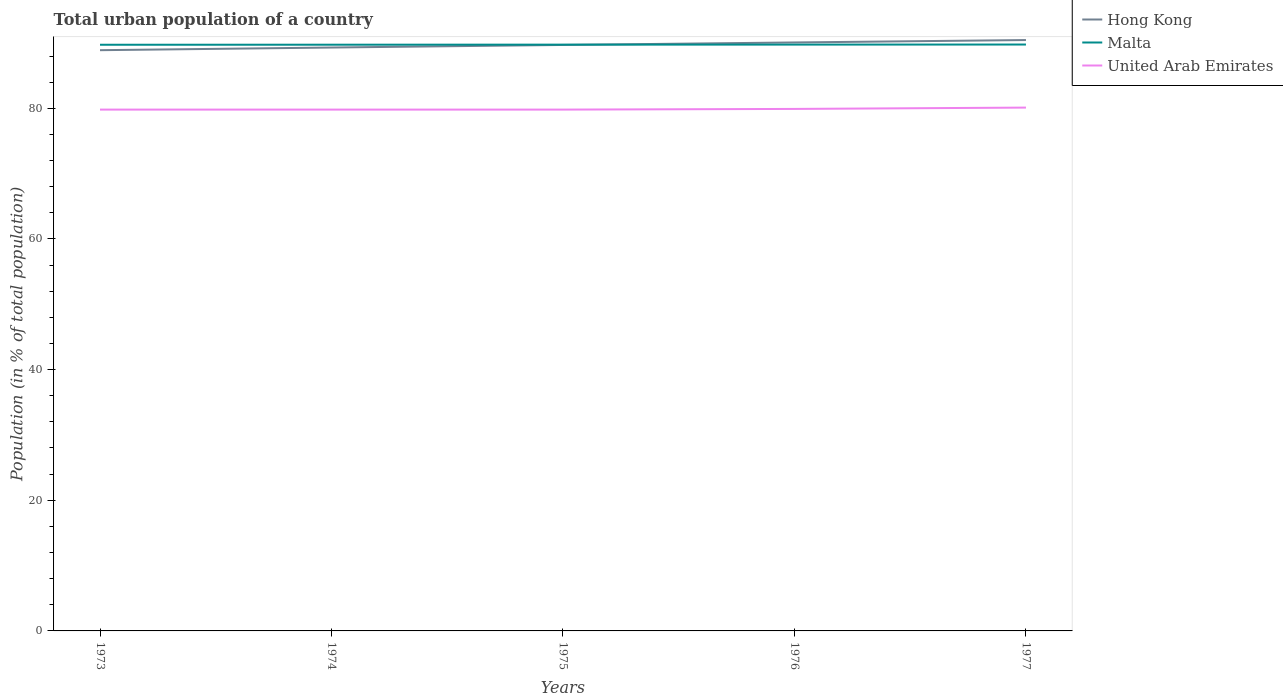Does the line corresponding to United Arab Emirates intersect with the line corresponding to Hong Kong?
Your answer should be very brief. No. Across all years, what is the maximum urban population in Malta?
Provide a short and direct response. 89.72. In which year was the urban population in Malta maximum?
Provide a short and direct response. 1973. What is the total urban population in Hong Kong in the graph?
Make the answer very short. -1.14. What is the difference between the highest and the second highest urban population in Hong Kong?
Provide a short and direct response. 1.55. What is the difference between the highest and the lowest urban population in Hong Kong?
Keep it short and to the point. 3. Is the urban population in Malta strictly greater than the urban population in Hong Kong over the years?
Your answer should be compact. No. How many years are there in the graph?
Your answer should be very brief. 5. How are the legend labels stacked?
Your answer should be very brief. Vertical. What is the title of the graph?
Keep it short and to the point. Total urban population of a country. What is the label or title of the Y-axis?
Provide a short and direct response. Population (in % of total population). What is the Population (in % of total population) in Hong Kong in 1973?
Make the answer very short. 88.89. What is the Population (in % of total population) of Malta in 1973?
Ensure brevity in your answer.  89.72. What is the Population (in % of total population) in United Arab Emirates in 1973?
Provide a short and direct response. 79.8. What is the Population (in % of total population) in Hong Kong in 1974?
Your answer should be very brief. 89.3. What is the Population (in % of total population) in Malta in 1974?
Ensure brevity in your answer.  89.73. What is the Population (in % of total population) of United Arab Emirates in 1974?
Offer a terse response. 79.8. What is the Population (in % of total population) in Hong Kong in 1975?
Give a very brief answer. 89.69. What is the Population (in % of total population) in Malta in 1975?
Your answer should be compact. 89.74. What is the Population (in % of total population) of United Arab Emirates in 1975?
Your response must be concise. 79.8. What is the Population (in % of total population) in Hong Kong in 1976?
Your answer should be very brief. 90.08. What is the Population (in % of total population) in Malta in 1976?
Your response must be concise. 89.75. What is the Population (in % of total population) of United Arab Emirates in 1976?
Provide a short and direct response. 79.9. What is the Population (in % of total population) of Hong Kong in 1977?
Your response must be concise. 90.44. What is the Population (in % of total population) of Malta in 1977?
Offer a terse response. 89.76. What is the Population (in % of total population) in United Arab Emirates in 1977?
Give a very brief answer. 80.11. Across all years, what is the maximum Population (in % of total population) in Hong Kong?
Provide a short and direct response. 90.44. Across all years, what is the maximum Population (in % of total population) of Malta?
Offer a terse response. 89.76. Across all years, what is the maximum Population (in % of total population) of United Arab Emirates?
Offer a terse response. 80.11. Across all years, what is the minimum Population (in % of total population) in Hong Kong?
Your response must be concise. 88.89. Across all years, what is the minimum Population (in % of total population) in Malta?
Provide a succinct answer. 89.72. Across all years, what is the minimum Population (in % of total population) of United Arab Emirates?
Your answer should be very brief. 79.8. What is the total Population (in % of total population) in Hong Kong in the graph?
Offer a terse response. 448.41. What is the total Population (in % of total population) in Malta in the graph?
Provide a short and direct response. 448.71. What is the total Population (in % of total population) in United Arab Emirates in the graph?
Make the answer very short. 399.41. What is the difference between the Population (in % of total population) of Hong Kong in 1973 and that in 1974?
Offer a terse response. -0.41. What is the difference between the Population (in % of total population) in Malta in 1973 and that in 1974?
Offer a terse response. -0.01. What is the difference between the Population (in % of total population) in United Arab Emirates in 1973 and that in 1974?
Your response must be concise. 0. What is the difference between the Population (in % of total population) in Hong Kong in 1973 and that in 1975?
Offer a terse response. -0.8. What is the difference between the Population (in % of total population) of Malta in 1973 and that in 1975?
Make the answer very short. -0.02. What is the difference between the Population (in % of total population) in Hong Kong in 1973 and that in 1976?
Keep it short and to the point. -1.18. What is the difference between the Population (in % of total population) in Malta in 1973 and that in 1976?
Ensure brevity in your answer.  -0.03. What is the difference between the Population (in % of total population) of United Arab Emirates in 1973 and that in 1976?
Your response must be concise. -0.1. What is the difference between the Population (in % of total population) in Hong Kong in 1973 and that in 1977?
Make the answer very short. -1.55. What is the difference between the Population (in % of total population) of Malta in 1973 and that in 1977?
Keep it short and to the point. -0.04. What is the difference between the Population (in % of total population) of United Arab Emirates in 1973 and that in 1977?
Your answer should be very brief. -0.31. What is the difference between the Population (in % of total population) in Hong Kong in 1974 and that in 1975?
Give a very brief answer. -0.39. What is the difference between the Population (in % of total population) of Malta in 1974 and that in 1975?
Ensure brevity in your answer.  -0.01. What is the difference between the Population (in % of total population) in United Arab Emirates in 1974 and that in 1975?
Ensure brevity in your answer.  0. What is the difference between the Population (in % of total population) of Hong Kong in 1974 and that in 1976?
Keep it short and to the point. -0.78. What is the difference between the Population (in % of total population) in Malta in 1974 and that in 1976?
Provide a succinct answer. -0.02. What is the difference between the Population (in % of total population) of United Arab Emirates in 1974 and that in 1976?
Offer a very short reply. -0.1. What is the difference between the Population (in % of total population) in Hong Kong in 1974 and that in 1977?
Offer a very short reply. -1.14. What is the difference between the Population (in % of total population) in Malta in 1974 and that in 1977?
Provide a short and direct response. -0.03. What is the difference between the Population (in % of total population) of United Arab Emirates in 1974 and that in 1977?
Offer a very short reply. -0.31. What is the difference between the Population (in % of total population) of Hong Kong in 1975 and that in 1976?
Make the answer very short. -0.38. What is the difference between the Population (in % of total population) in Malta in 1975 and that in 1976?
Offer a terse response. -0.01. What is the difference between the Population (in % of total population) of United Arab Emirates in 1975 and that in 1976?
Offer a terse response. -0.1. What is the difference between the Population (in % of total population) in Hong Kong in 1975 and that in 1977?
Provide a succinct answer. -0.75. What is the difference between the Population (in % of total population) of Malta in 1975 and that in 1977?
Your answer should be very brief. -0.02. What is the difference between the Population (in % of total population) of United Arab Emirates in 1975 and that in 1977?
Ensure brevity in your answer.  -0.31. What is the difference between the Population (in % of total population) in Hong Kong in 1976 and that in 1977?
Your response must be concise. -0.37. What is the difference between the Population (in % of total population) of Malta in 1976 and that in 1977?
Provide a succinct answer. -0.01. What is the difference between the Population (in % of total population) in United Arab Emirates in 1976 and that in 1977?
Keep it short and to the point. -0.2. What is the difference between the Population (in % of total population) of Hong Kong in 1973 and the Population (in % of total population) of Malta in 1974?
Provide a succinct answer. -0.84. What is the difference between the Population (in % of total population) in Hong Kong in 1973 and the Population (in % of total population) in United Arab Emirates in 1974?
Offer a terse response. 9.09. What is the difference between the Population (in % of total population) in Malta in 1973 and the Population (in % of total population) in United Arab Emirates in 1974?
Ensure brevity in your answer.  9.93. What is the difference between the Population (in % of total population) in Hong Kong in 1973 and the Population (in % of total population) in Malta in 1975?
Your response must be concise. -0.85. What is the difference between the Population (in % of total population) of Hong Kong in 1973 and the Population (in % of total population) of United Arab Emirates in 1975?
Give a very brief answer. 9.09. What is the difference between the Population (in % of total population) of Malta in 1973 and the Population (in % of total population) of United Arab Emirates in 1975?
Provide a succinct answer. 9.93. What is the difference between the Population (in % of total population) in Hong Kong in 1973 and the Population (in % of total population) in Malta in 1976?
Provide a short and direct response. -0.86. What is the difference between the Population (in % of total population) of Hong Kong in 1973 and the Population (in % of total population) of United Arab Emirates in 1976?
Ensure brevity in your answer.  8.99. What is the difference between the Population (in % of total population) in Malta in 1973 and the Population (in % of total population) in United Arab Emirates in 1976?
Offer a very short reply. 9.82. What is the difference between the Population (in % of total population) of Hong Kong in 1973 and the Population (in % of total population) of Malta in 1977?
Your answer should be compact. -0.87. What is the difference between the Population (in % of total population) in Hong Kong in 1973 and the Population (in % of total population) in United Arab Emirates in 1977?
Offer a very short reply. 8.79. What is the difference between the Population (in % of total population) in Malta in 1973 and the Population (in % of total population) in United Arab Emirates in 1977?
Your answer should be very brief. 9.62. What is the difference between the Population (in % of total population) of Hong Kong in 1974 and the Population (in % of total population) of Malta in 1975?
Keep it short and to the point. -0.44. What is the difference between the Population (in % of total population) in Hong Kong in 1974 and the Population (in % of total population) in United Arab Emirates in 1975?
Offer a very short reply. 9.5. What is the difference between the Population (in % of total population) in Malta in 1974 and the Population (in % of total population) in United Arab Emirates in 1975?
Provide a short and direct response. 9.93. What is the difference between the Population (in % of total population) of Hong Kong in 1974 and the Population (in % of total population) of Malta in 1976?
Give a very brief answer. -0.45. What is the difference between the Population (in % of total population) of Hong Kong in 1974 and the Population (in % of total population) of United Arab Emirates in 1976?
Ensure brevity in your answer.  9.4. What is the difference between the Population (in % of total population) in Malta in 1974 and the Population (in % of total population) in United Arab Emirates in 1976?
Give a very brief answer. 9.83. What is the difference between the Population (in % of total population) in Hong Kong in 1974 and the Population (in % of total population) in Malta in 1977?
Your answer should be very brief. -0.46. What is the difference between the Population (in % of total population) in Hong Kong in 1974 and the Population (in % of total population) in United Arab Emirates in 1977?
Offer a very short reply. 9.2. What is the difference between the Population (in % of total population) of Malta in 1974 and the Population (in % of total population) of United Arab Emirates in 1977?
Your answer should be compact. 9.63. What is the difference between the Population (in % of total population) in Hong Kong in 1975 and the Population (in % of total population) in Malta in 1976?
Ensure brevity in your answer.  -0.06. What is the difference between the Population (in % of total population) in Hong Kong in 1975 and the Population (in % of total population) in United Arab Emirates in 1976?
Your answer should be compact. 9.79. What is the difference between the Population (in % of total population) in Malta in 1975 and the Population (in % of total population) in United Arab Emirates in 1976?
Ensure brevity in your answer.  9.84. What is the difference between the Population (in % of total population) in Hong Kong in 1975 and the Population (in % of total population) in Malta in 1977?
Your answer should be very brief. -0.07. What is the difference between the Population (in % of total population) of Hong Kong in 1975 and the Population (in % of total population) of United Arab Emirates in 1977?
Ensure brevity in your answer.  9.59. What is the difference between the Population (in % of total population) of Malta in 1975 and the Population (in % of total population) of United Arab Emirates in 1977?
Your response must be concise. 9.64. What is the difference between the Population (in % of total population) of Hong Kong in 1976 and the Population (in % of total population) of Malta in 1977?
Make the answer very short. 0.32. What is the difference between the Population (in % of total population) of Hong Kong in 1976 and the Population (in % of total population) of United Arab Emirates in 1977?
Ensure brevity in your answer.  9.97. What is the difference between the Population (in % of total population) of Malta in 1976 and the Population (in % of total population) of United Arab Emirates in 1977?
Make the answer very short. 9.64. What is the average Population (in % of total population) of Hong Kong per year?
Your answer should be very brief. 89.68. What is the average Population (in % of total population) of Malta per year?
Keep it short and to the point. 89.74. What is the average Population (in % of total population) of United Arab Emirates per year?
Provide a succinct answer. 79.88. In the year 1973, what is the difference between the Population (in % of total population) in Hong Kong and Population (in % of total population) in Malta?
Give a very brief answer. -0.83. In the year 1973, what is the difference between the Population (in % of total population) in Hong Kong and Population (in % of total population) in United Arab Emirates?
Give a very brief answer. 9.09. In the year 1973, what is the difference between the Population (in % of total population) of Malta and Population (in % of total population) of United Arab Emirates?
Offer a terse response. 9.93. In the year 1974, what is the difference between the Population (in % of total population) of Hong Kong and Population (in % of total population) of Malta?
Make the answer very short. -0.43. In the year 1974, what is the difference between the Population (in % of total population) in Hong Kong and Population (in % of total population) in United Arab Emirates?
Keep it short and to the point. 9.5. In the year 1974, what is the difference between the Population (in % of total population) of Malta and Population (in % of total population) of United Arab Emirates?
Make the answer very short. 9.93. In the year 1975, what is the difference between the Population (in % of total population) of Hong Kong and Population (in % of total population) of Malta?
Give a very brief answer. -0.05. In the year 1975, what is the difference between the Population (in % of total population) in Hong Kong and Population (in % of total population) in United Arab Emirates?
Your answer should be compact. 9.89. In the year 1975, what is the difference between the Population (in % of total population) in Malta and Population (in % of total population) in United Arab Emirates?
Offer a terse response. 9.94. In the year 1976, what is the difference between the Population (in % of total population) of Hong Kong and Population (in % of total population) of Malta?
Provide a short and direct response. 0.33. In the year 1976, what is the difference between the Population (in % of total population) in Hong Kong and Population (in % of total population) in United Arab Emirates?
Make the answer very short. 10.17. In the year 1976, what is the difference between the Population (in % of total population) of Malta and Population (in % of total population) of United Arab Emirates?
Provide a short and direct response. 9.85. In the year 1977, what is the difference between the Population (in % of total population) in Hong Kong and Population (in % of total population) in Malta?
Provide a short and direct response. 0.69. In the year 1977, what is the difference between the Population (in % of total population) of Hong Kong and Population (in % of total population) of United Arab Emirates?
Your response must be concise. 10.34. In the year 1977, what is the difference between the Population (in % of total population) in Malta and Population (in % of total population) in United Arab Emirates?
Offer a terse response. 9.65. What is the ratio of the Population (in % of total population) in Hong Kong in 1973 to that in 1974?
Offer a very short reply. 1. What is the ratio of the Population (in % of total population) of Hong Kong in 1973 to that in 1976?
Make the answer very short. 0.99. What is the ratio of the Population (in % of total population) of Malta in 1973 to that in 1976?
Your response must be concise. 1. What is the ratio of the Population (in % of total population) in United Arab Emirates in 1973 to that in 1976?
Your answer should be very brief. 1. What is the ratio of the Population (in % of total population) in Hong Kong in 1973 to that in 1977?
Offer a terse response. 0.98. What is the ratio of the Population (in % of total population) in Malta in 1973 to that in 1977?
Your answer should be compact. 1. What is the ratio of the Population (in % of total population) of United Arab Emirates in 1973 to that in 1977?
Offer a very short reply. 1. What is the ratio of the Population (in % of total population) of Hong Kong in 1974 to that in 1975?
Keep it short and to the point. 1. What is the ratio of the Population (in % of total population) of Malta in 1974 to that in 1975?
Offer a very short reply. 1. What is the ratio of the Population (in % of total population) of Hong Kong in 1974 to that in 1976?
Your answer should be compact. 0.99. What is the ratio of the Population (in % of total population) of Malta in 1974 to that in 1976?
Ensure brevity in your answer.  1. What is the ratio of the Population (in % of total population) of Hong Kong in 1974 to that in 1977?
Ensure brevity in your answer.  0.99. What is the ratio of the Population (in % of total population) of Malta in 1975 to that in 1976?
Offer a very short reply. 1. What is the ratio of the Population (in % of total population) in Malta in 1975 to that in 1977?
Offer a terse response. 1. What is the ratio of the Population (in % of total population) of United Arab Emirates in 1975 to that in 1977?
Give a very brief answer. 1. What is the ratio of the Population (in % of total population) of Hong Kong in 1976 to that in 1977?
Ensure brevity in your answer.  1. What is the ratio of the Population (in % of total population) of Malta in 1976 to that in 1977?
Provide a succinct answer. 1. What is the ratio of the Population (in % of total population) in United Arab Emirates in 1976 to that in 1977?
Your response must be concise. 1. What is the difference between the highest and the second highest Population (in % of total population) of Hong Kong?
Your response must be concise. 0.37. What is the difference between the highest and the second highest Population (in % of total population) of Malta?
Your answer should be compact. 0.01. What is the difference between the highest and the second highest Population (in % of total population) in United Arab Emirates?
Provide a short and direct response. 0.2. What is the difference between the highest and the lowest Population (in % of total population) in Hong Kong?
Offer a terse response. 1.55. What is the difference between the highest and the lowest Population (in % of total population) of Malta?
Provide a short and direct response. 0.04. What is the difference between the highest and the lowest Population (in % of total population) in United Arab Emirates?
Give a very brief answer. 0.31. 